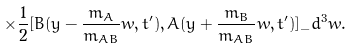Convert formula to latex. <formula><loc_0><loc_0><loc_500><loc_500>\times \frac { 1 } { 2 } [ B ( { y } - \frac { m _ { A } } { m _ { A B } } { w } , t ^ { \prime } ) , A ( { y } + \frac { m _ { B } } { m _ { A B } } { w } , t ^ { \prime } ) ] _ { - } d ^ { 3 } w .</formula> 